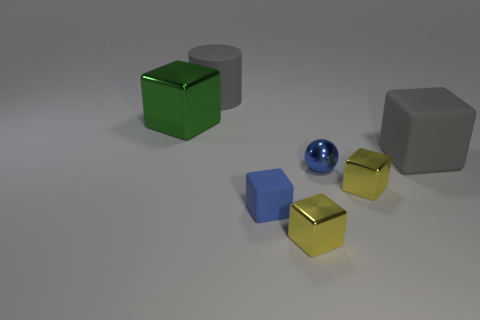Subtract all blue matte blocks. How many blocks are left? 4 Subtract all blue blocks. How many blocks are left? 4 Add 1 gray objects. How many objects exist? 8 Subtract all cyan cubes. Subtract all green cylinders. How many cubes are left? 5 Subtract all cylinders. How many objects are left? 6 Add 7 small purple metal spheres. How many small purple metal spheres exist? 7 Subtract 0 brown cylinders. How many objects are left? 7 Subtract all small matte blocks. Subtract all yellow blocks. How many objects are left? 4 Add 6 metal spheres. How many metal spheres are left? 7 